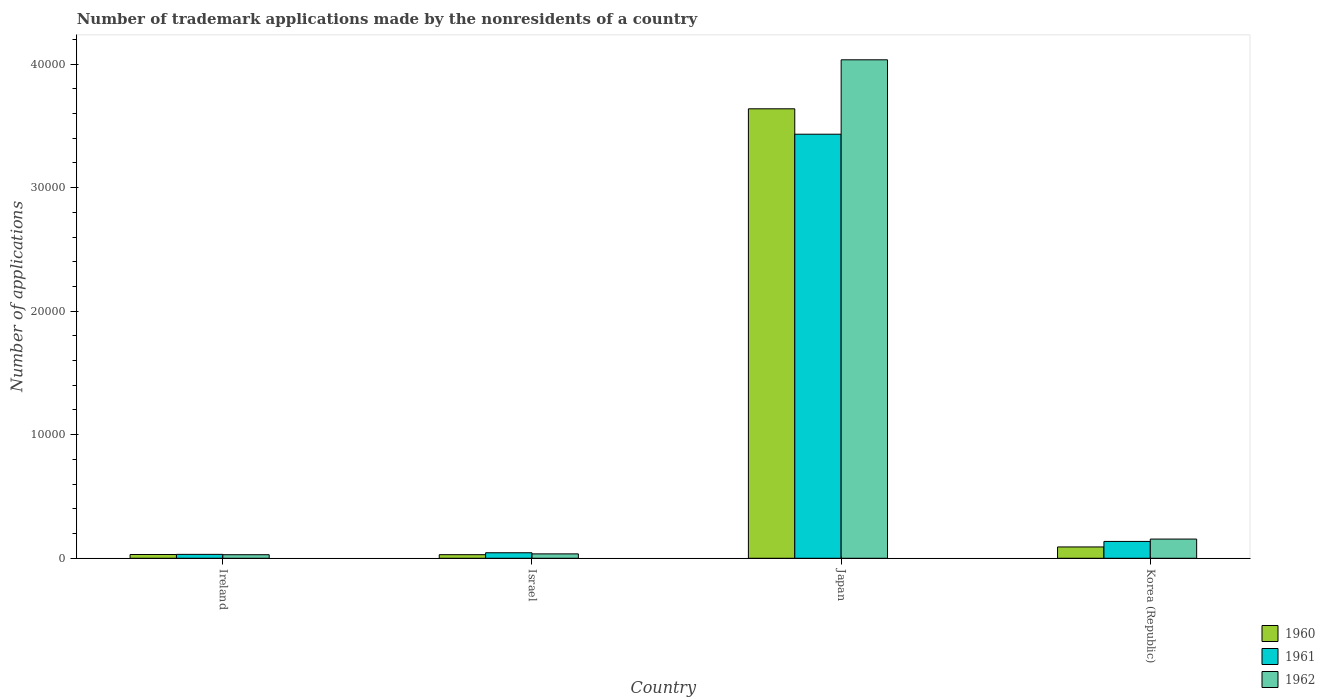How many bars are there on the 3rd tick from the right?
Give a very brief answer. 3. In how many cases, is the number of bars for a given country not equal to the number of legend labels?
Make the answer very short. 0. What is the number of trademark applications made by the nonresidents in 1961 in Japan?
Your response must be concise. 3.43e+04. Across all countries, what is the maximum number of trademark applications made by the nonresidents in 1962?
Offer a very short reply. 4.03e+04. Across all countries, what is the minimum number of trademark applications made by the nonresidents in 1961?
Your answer should be very brief. 316. In which country was the number of trademark applications made by the nonresidents in 1961 minimum?
Your response must be concise. Ireland. What is the total number of trademark applications made by the nonresidents in 1961 in the graph?
Provide a short and direct response. 3.64e+04. What is the difference between the number of trademark applications made by the nonresidents in 1960 in Japan and that in Korea (Republic)?
Your answer should be compact. 3.55e+04. What is the difference between the number of trademark applications made by the nonresidents in 1962 in Ireland and the number of trademark applications made by the nonresidents in 1960 in Korea (Republic)?
Ensure brevity in your answer.  -628. What is the average number of trademark applications made by the nonresidents in 1960 per country?
Your answer should be very brief. 9472. What is the difference between the number of trademark applications made by the nonresidents of/in 1960 and number of trademark applications made by the nonresidents of/in 1962 in Japan?
Offer a terse response. -3966. What is the ratio of the number of trademark applications made by the nonresidents in 1961 in Ireland to that in Korea (Republic)?
Keep it short and to the point. 0.23. Is the difference between the number of trademark applications made by the nonresidents in 1960 in Japan and Korea (Republic) greater than the difference between the number of trademark applications made by the nonresidents in 1962 in Japan and Korea (Republic)?
Provide a short and direct response. No. What is the difference between the highest and the second highest number of trademark applications made by the nonresidents in 1960?
Your response must be concise. 3.55e+04. What is the difference between the highest and the lowest number of trademark applications made by the nonresidents in 1962?
Offer a terse response. 4.01e+04. In how many countries, is the number of trademark applications made by the nonresidents in 1962 greater than the average number of trademark applications made by the nonresidents in 1962 taken over all countries?
Keep it short and to the point. 1. Is it the case that in every country, the sum of the number of trademark applications made by the nonresidents in 1960 and number of trademark applications made by the nonresidents in 1961 is greater than the number of trademark applications made by the nonresidents in 1962?
Keep it short and to the point. Yes. Are all the bars in the graph horizontal?
Your response must be concise. No. How many countries are there in the graph?
Offer a very short reply. 4. What is the difference between two consecutive major ticks on the Y-axis?
Your response must be concise. 10000. Are the values on the major ticks of Y-axis written in scientific E-notation?
Keep it short and to the point. No. Does the graph contain grids?
Your answer should be compact. No. Where does the legend appear in the graph?
Give a very brief answer. Bottom right. What is the title of the graph?
Offer a terse response. Number of trademark applications made by the nonresidents of a country. What is the label or title of the X-axis?
Provide a succinct answer. Country. What is the label or title of the Y-axis?
Provide a succinct answer. Number of applications. What is the Number of applications in 1960 in Ireland?
Ensure brevity in your answer.  305. What is the Number of applications in 1961 in Ireland?
Give a very brief answer. 316. What is the Number of applications in 1962 in Ireland?
Your answer should be very brief. 288. What is the Number of applications in 1960 in Israel?
Offer a terse response. 290. What is the Number of applications in 1961 in Israel?
Offer a terse response. 446. What is the Number of applications in 1962 in Israel?
Offer a terse response. 355. What is the Number of applications in 1960 in Japan?
Give a very brief answer. 3.64e+04. What is the Number of applications in 1961 in Japan?
Offer a terse response. 3.43e+04. What is the Number of applications in 1962 in Japan?
Offer a terse response. 4.03e+04. What is the Number of applications of 1960 in Korea (Republic)?
Provide a short and direct response. 916. What is the Number of applications of 1961 in Korea (Republic)?
Your answer should be very brief. 1363. What is the Number of applications in 1962 in Korea (Republic)?
Offer a terse response. 1554. Across all countries, what is the maximum Number of applications of 1960?
Provide a succinct answer. 3.64e+04. Across all countries, what is the maximum Number of applications in 1961?
Offer a very short reply. 3.43e+04. Across all countries, what is the maximum Number of applications of 1962?
Provide a succinct answer. 4.03e+04. Across all countries, what is the minimum Number of applications in 1960?
Your answer should be compact. 290. Across all countries, what is the minimum Number of applications in 1961?
Give a very brief answer. 316. Across all countries, what is the minimum Number of applications of 1962?
Give a very brief answer. 288. What is the total Number of applications of 1960 in the graph?
Your answer should be very brief. 3.79e+04. What is the total Number of applications in 1961 in the graph?
Provide a succinct answer. 3.64e+04. What is the total Number of applications of 1962 in the graph?
Give a very brief answer. 4.25e+04. What is the difference between the Number of applications of 1961 in Ireland and that in Israel?
Your answer should be compact. -130. What is the difference between the Number of applications in 1962 in Ireland and that in Israel?
Offer a terse response. -67. What is the difference between the Number of applications in 1960 in Ireland and that in Japan?
Make the answer very short. -3.61e+04. What is the difference between the Number of applications of 1961 in Ireland and that in Japan?
Provide a short and direct response. -3.40e+04. What is the difference between the Number of applications in 1962 in Ireland and that in Japan?
Offer a very short reply. -4.01e+04. What is the difference between the Number of applications in 1960 in Ireland and that in Korea (Republic)?
Offer a terse response. -611. What is the difference between the Number of applications in 1961 in Ireland and that in Korea (Republic)?
Make the answer very short. -1047. What is the difference between the Number of applications in 1962 in Ireland and that in Korea (Republic)?
Keep it short and to the point. -1266. What is the difference between the Number of applications of 1960 in Israel and that in Japan?
Give a very brief answer. -3.61e+04. What is the difference between the Number of applications in 1961 in Israel and that in Japan?
Your response must be concise. -3.39e+04. What is the difference between the Number of applications of 1962 in Israel and that in Japan?
Your response must be concise. -4.00e+04. What is the difference between the Number of applications of 1960 in Israel and that in Korea (Republic)?
Make the answer very short. -626. What is the difference between the Number of applications of 1961 in Israel and that in Korea (Republic)?
Keep it short and to the point. -917. What is the difference between the Number of applications in 1962 in Israel and that in Korea (Republic)?
Give a very brief answer. -1199. What is the difference between the Number of applications of 1960 in Japan and that in Korea (Republic)?
Offer a terse response. 3.55e+04. What is the difference between the Number of applications of 1961 in Japan and that in Korea (Republic)?
Your answer should be compact. 3.30e+04. What is the difference between the Number of applications in 1962 in Japan and that in Korea (Republic)?
Offer a very short reply. 3.88e+04. What is the difference between the Number of applications in 1960 in Ireland and the Number of applications in 1961 in Israel?
Your answer should be compact. -141. What is the difference between the Number of applications of 1961 in Ireland and the Number of applications of 1962 in Israel?
Offer a very short reply. -39. What is the difference between the Number of applications of 1960 in Ireland and the Number of applications of 1961 in Japan?
Keep it short and to the point. -3.40e+04. What is the difference between the Number of applications in 1960 in Ireland and the Number of applications in 1962 in Japan?
Make the answer very short. -4.00e+04. What is the difference between the Number of applications of 1961 in Ireland and the Number of applications of 1962 in Japan?
Your answer should be compact. -4.00e+04. What is the difference between the Number of applications in 1960 in Ireland and the Number of applications in 1961 in Korea (Republic)?
Offer a very short reply. -1058. What is the difference between the Number of applications in 1960 in Ireland and the Number of applications in 1962 in Korea (Republic)?
Offer a terse response. -1249. What is the difference between the Number of applications of 1961 in Ireland and the Number of applications of 1962 in Korea (Republic)?
Provide a short and direct response. -1238. What is the difference between the Number of applications of 1960 in Israel and the Number of applications of 1961 in Japan?
Make the answer very short. -3.40e+04. What is the difference between the Number of applications of 1960 in Israel and the Number of applications of 1962 in Japan?
Your answer should be compact. -4.01e+04. What is the difference between the Number of applications of 1961 in Israel and the Number of applications of 1962 in Japan?
Offer a terse response. -3.99e+04. What is the difference between the Number of applications in 1960 in Israel and the Number of applications in 1961 in Korea (Republic)?
Offer a terse response. -1073. What is the difference between the Number of applications of 1960 in Israel and the Number of applications of 1962 in Korea (Republic)?
Your answer should be very brief. -1264. What is the difference between the Number of applications of 1961 in Israel and the Number of applications of 1962 in Korea (Republic)?
Your response must be concise. -1108. What is the difference between the Number of applications of 1960 in Japan and the Number of applications of 1961 in Korea (Republic)?
Offer a terse response. 3.50e+04. What is the difference between the Number of applications in 1960 in Japan and the Number of applications in 1962 in Korea (Republic)?
Provide a succinct answer. 3.48e+04. What is the difference between the Number of applications in 1961 in Japan and the Number of applications in 1962 in Korea (Republic)?
Provide a succinct answer. 3.28e+04. What is the average Number of applications of 1960 per country?
Provide a short and direct response. 9472. What is the average Number of applications in 1961 per country?
Make the answer very short. 9111.25. What is the average Number of applications of 1962 per country?
Provide a short and direct response. 1.06e+04. What is the difference between the Number of applications of 1960 and Number of applications of 1961 in Ireland?
Give a very brief answer. -11. What is the difference between the Number of applications of 1960 and Number of applications of 1961 in Israel?
Offer a very short reply. -156. What is the difference between the Number of applications of 1960 and Number of applications of 1962 in Israel?
Keep it short and to the point. -65. What is the difference between the Number of applications of 1961 and Number of applications of 1962 in Israel?
Give a very brief answer. 91. What is the difference between the Number of applications of 1960 and Number of applications of 1961 in Japan?
Make the answer very short. 2057. What is the difference between the Number of applications in 1960 and Number of applications in 1962 in Japan?
Provide a succinct answer. -3966. What is the difference between the Number of applications of 1961 and Number of applications of 1962 in Japan?
Provide a succinct answer. -6023. What is the difference between the Number of applications in 1960 and Number of applications in 1961 in Korea (Republic)?
Give a very brief answer. -447. What is the difference between the Number of applications of 1960 and Number of applications of 1962 in Korea (Republic)?
Offer a very short reply. -638. What is the difference between the Number of applications in 1961 and Number of applications in 1962 in Korea (Republic)?
Your response must be concise. -191. What is the ratio of the Number of applications of 1960 in Ireland to that in Israel?
Provide a succinct answer. 1.05. What is the ratio of the Number of applications of 1961 in Ireland to that in Israel?
Your response must be concise. 0.71. What is the ratio of the Number of applications of 1962 in Ireland to that in Israel?
Give a very brief answer. 0.81. What is the ratio of the Number of applications of 1960 in Ireland to that in Japan?
Offer a very short reply. 0.01. What is the ratio of the Number of applications in 1961 in Ireland to that in Japan?
Your response must be concise. 0.01. What is the ratio of the Number of applications of 1962 in Ireland to that in Japan?
Offer a very short reply. 0.01. What is the ratio of the Number of applications in 1960 in Ireland to that in Korea (Republic)?
Keep it short and to the point. 0.33. What is the ratio of the Number of applications of 1961 in Ireland to that in Korea (Republic)?
Your response must be concise. 0.23. What is the ratio of the Number of applications of 1962 in Ireland to that in Korea (Republic)?
Provide a succinct answer. 0.19. What is the ratio of the Number of applications of 1960 in Israel to that in Japan?
Keep it short and to the point. 0.01. What is the ratio of the Number of applications in 1961 in Israel to that in Japan?
Give a very brief answer. 0.01. What is the ratio of the Number of applications of 1962 in Israel to that in Japan?
Offer a very short reply. 0.01. What is the ratio of the Number of applications in 1960 in Israel to that in Korea (Republic)?
Ensure brevity in your answer.  0.32. What is the ratio of the Number of applications in 1961 in Israel to that in Korea (Republic)?
Your answer should be very brief. 0.33. What is the ratio of the Number of applications in 1962 in Israel to that in Korea (Republic)?
Ensure brevity in your answer.  0.23. What is the ratio of the Number of applications of 1960 in Japan to that in Korea (Republic)?
Provide a succinct answer. 39.71. What is the ratio of the Number of applications in 1961 in Japan to that in Korea (Republic)?
Keep it short and to the point. 25.18. What is the ratio of the Number of applications of 1962 in Japan to that in Korea (Republic)?
Your answer should be very brief. 25.96. What is the difference between the highest and the second highest Number of applications of 1960?
Your answer should be compact. 3.55e+04. What is the difference between the highest and the second highest Number of applications of 1961?
Your answer should be compact. 3.30e+04. What is the difference between the highest and the second highest Number of applications in 1962?
Keep it short and to the point. 3.88e+04. What is the difference between the highest and the lowest Number of applications of 1960?
Provide a succinct answer. 3.61e+04. What is the difference between the highest and the lowest Number of applications of 1961?
Give a very brief answer. 3.40e+04. What is the difference between the highest and the lowest Number of applications of 1962?
Ensure brevity in your answer.  4.01e+04. 